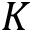<formula> <loc_0><loc_0><loc_500><loc_500>K</formula> 